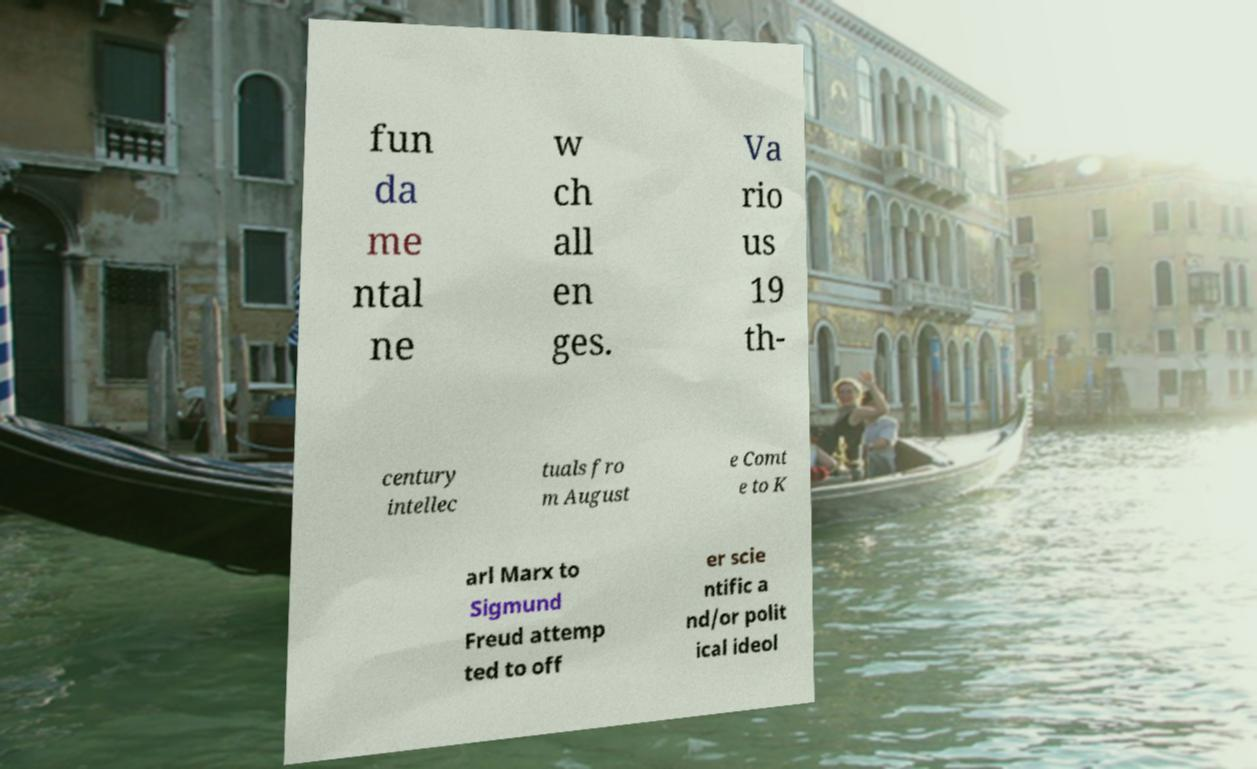What messages or text are displayed in this image? I need them in a readable, typed format. fun da me ntal ne w ch all en ges. Va rio us 19 th- century intellec tuals fro m August e Comt e to K arl Marx to Sigmund Freud attemp ted to off er scie ntific a nd/or polit ical ideol 